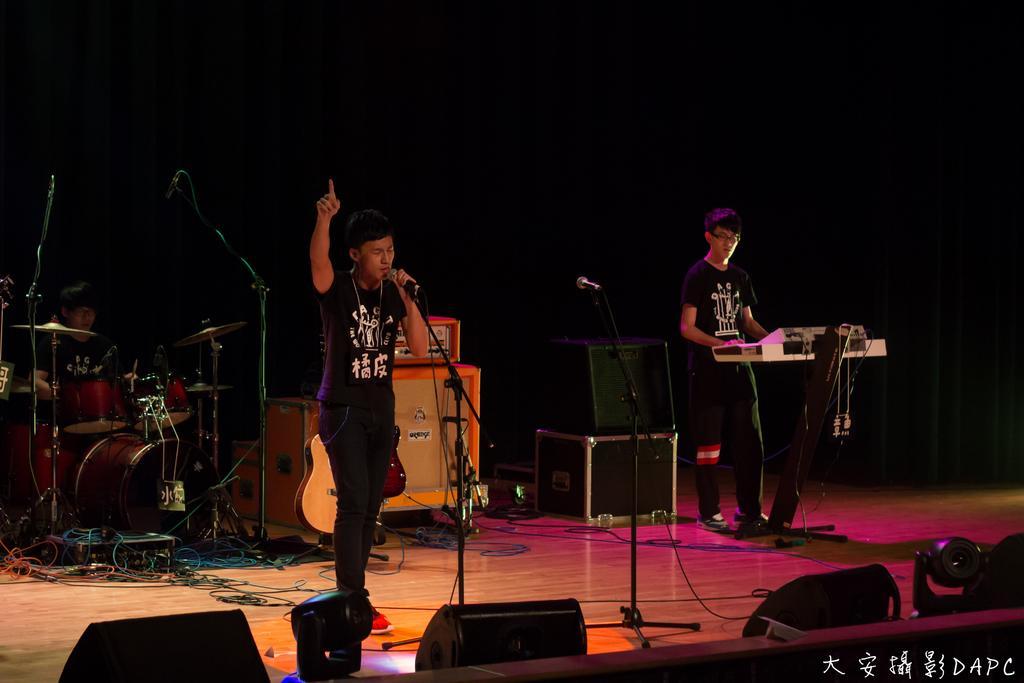Could you give a brief overview of what you see in this image? In this picture we can see three people, one man is singing with the help of microphone and one man is playing key board, in the background we can see a person is playing drums in front of microphones, and also we can see a guitar and a speaker. 